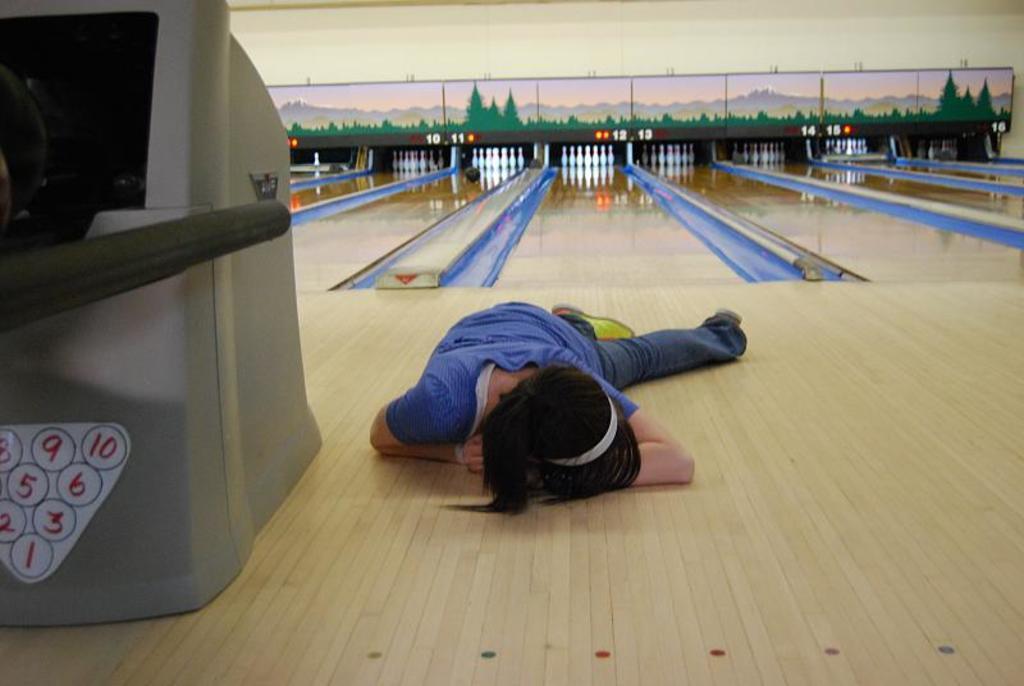In one or two sentences, can you explain what this image depicts? In the foreground of this image, there is a person laying on the floor. On the left, there is an object. In the background, there is a bowling game alley. 